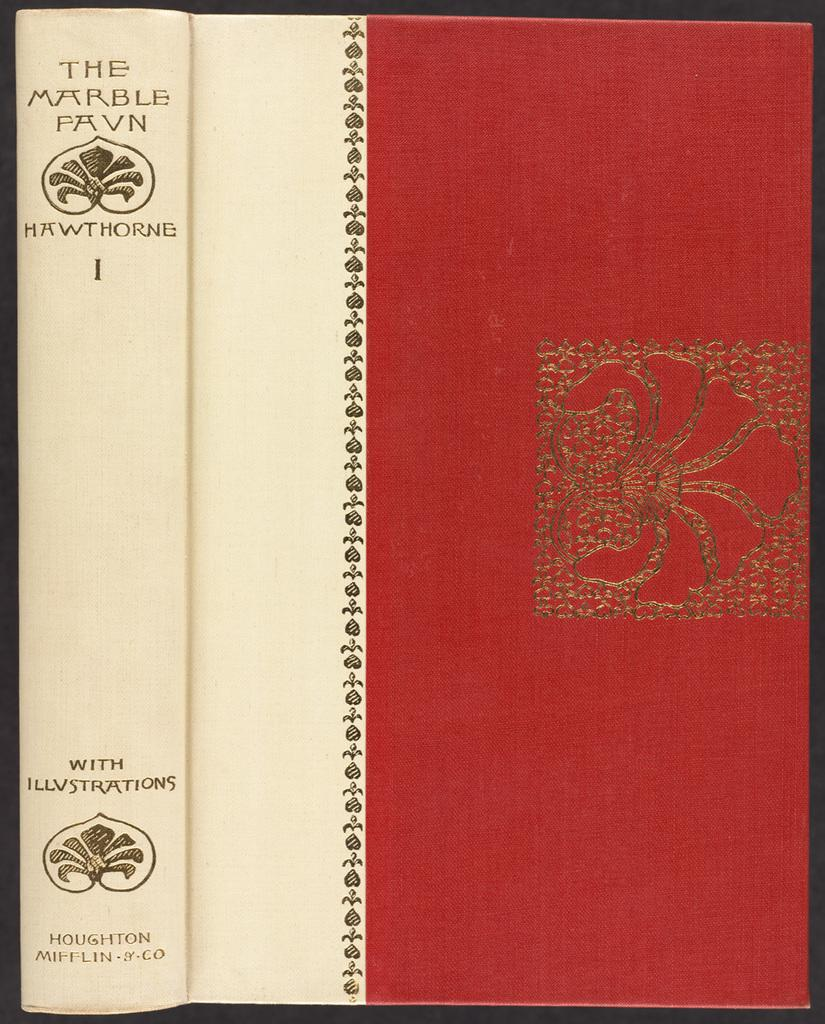<image>
Relay a brief, clear account of the picture shown. The cover of the book shown states that there are illustrations in the book. 